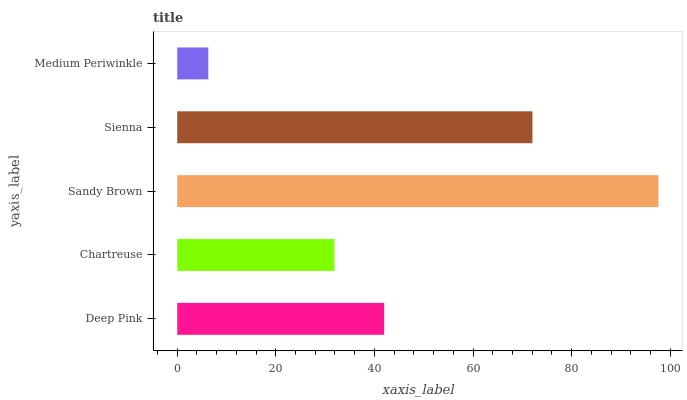Is Medium Periwinkle the minimum?
Answer yes or no. Yes. Is Sandy Brown the maximum?
Answer yes or no. Yes. Is Chartreuse the minimum?
Answer yes or no. No. Is Chartreuse the maximum?
Answer yes or no. No. Is Deep Pink greater than Chartreuse?
Answer yes or no. Yes. Is Chartreuse less than Deep Pink?
Answer yes or no. Yes. Is Chartreuse greater than Deep Pink?
Answer yes or no. No. Is Deep Pink less than Chartreuse?
Answer yes or no. No. Is Deep Pink the high median?
Answer yes or no. Yes. Is Deep Pink the low median?
Answer yes or no. Yes. Is Medium Periwinkle the high median?
Answer yes or no. No. Is Sandy Brown the low median?
Answer yes or no. No. 